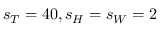Convert formula to latex. <formula><loc_0><loc_0><loc_500><loc_500>s _ { T } = 4 0 , s _ { H } = s _ { W } = 2</formula> 